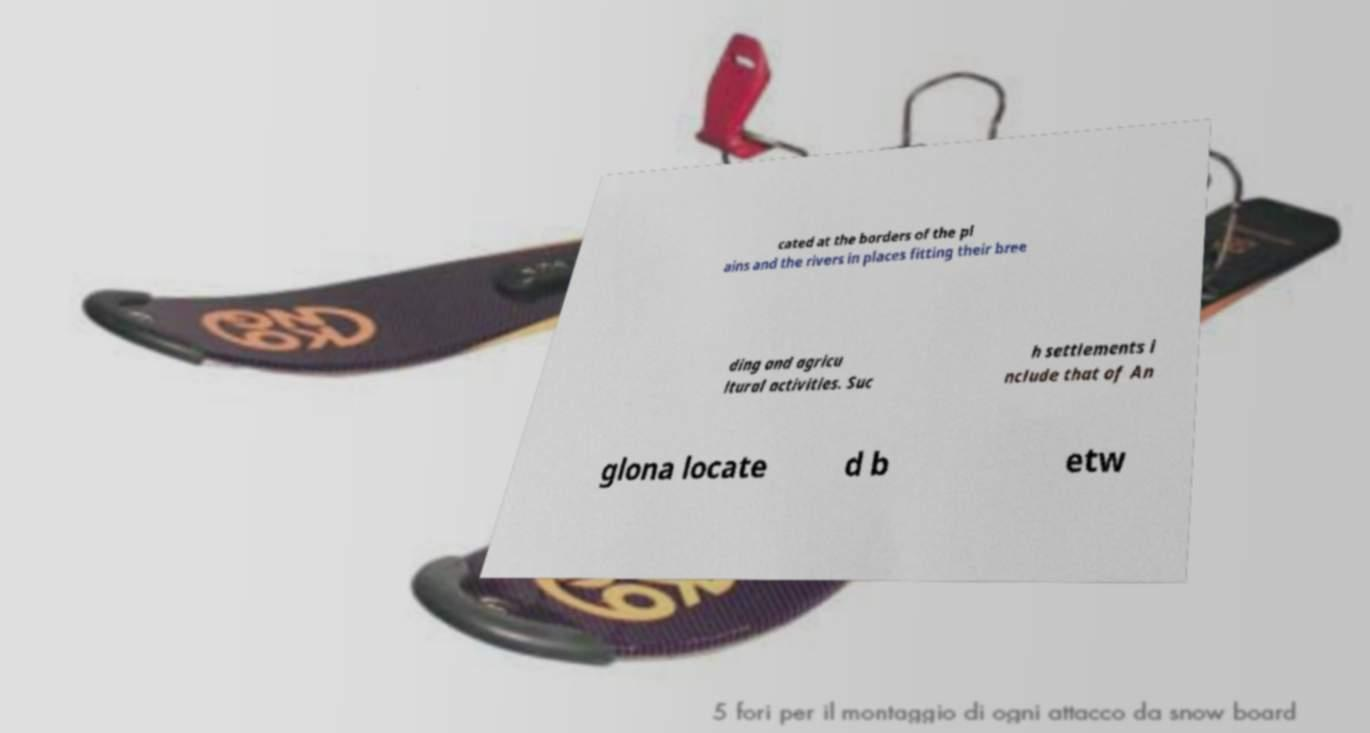Could you extract and type out the text from this image? cated at the borders of the pl ains and the rivers in places fitting their bree ding and agricu ltural activities. Suc h settlements i nclude that of An glona locate d b etw 